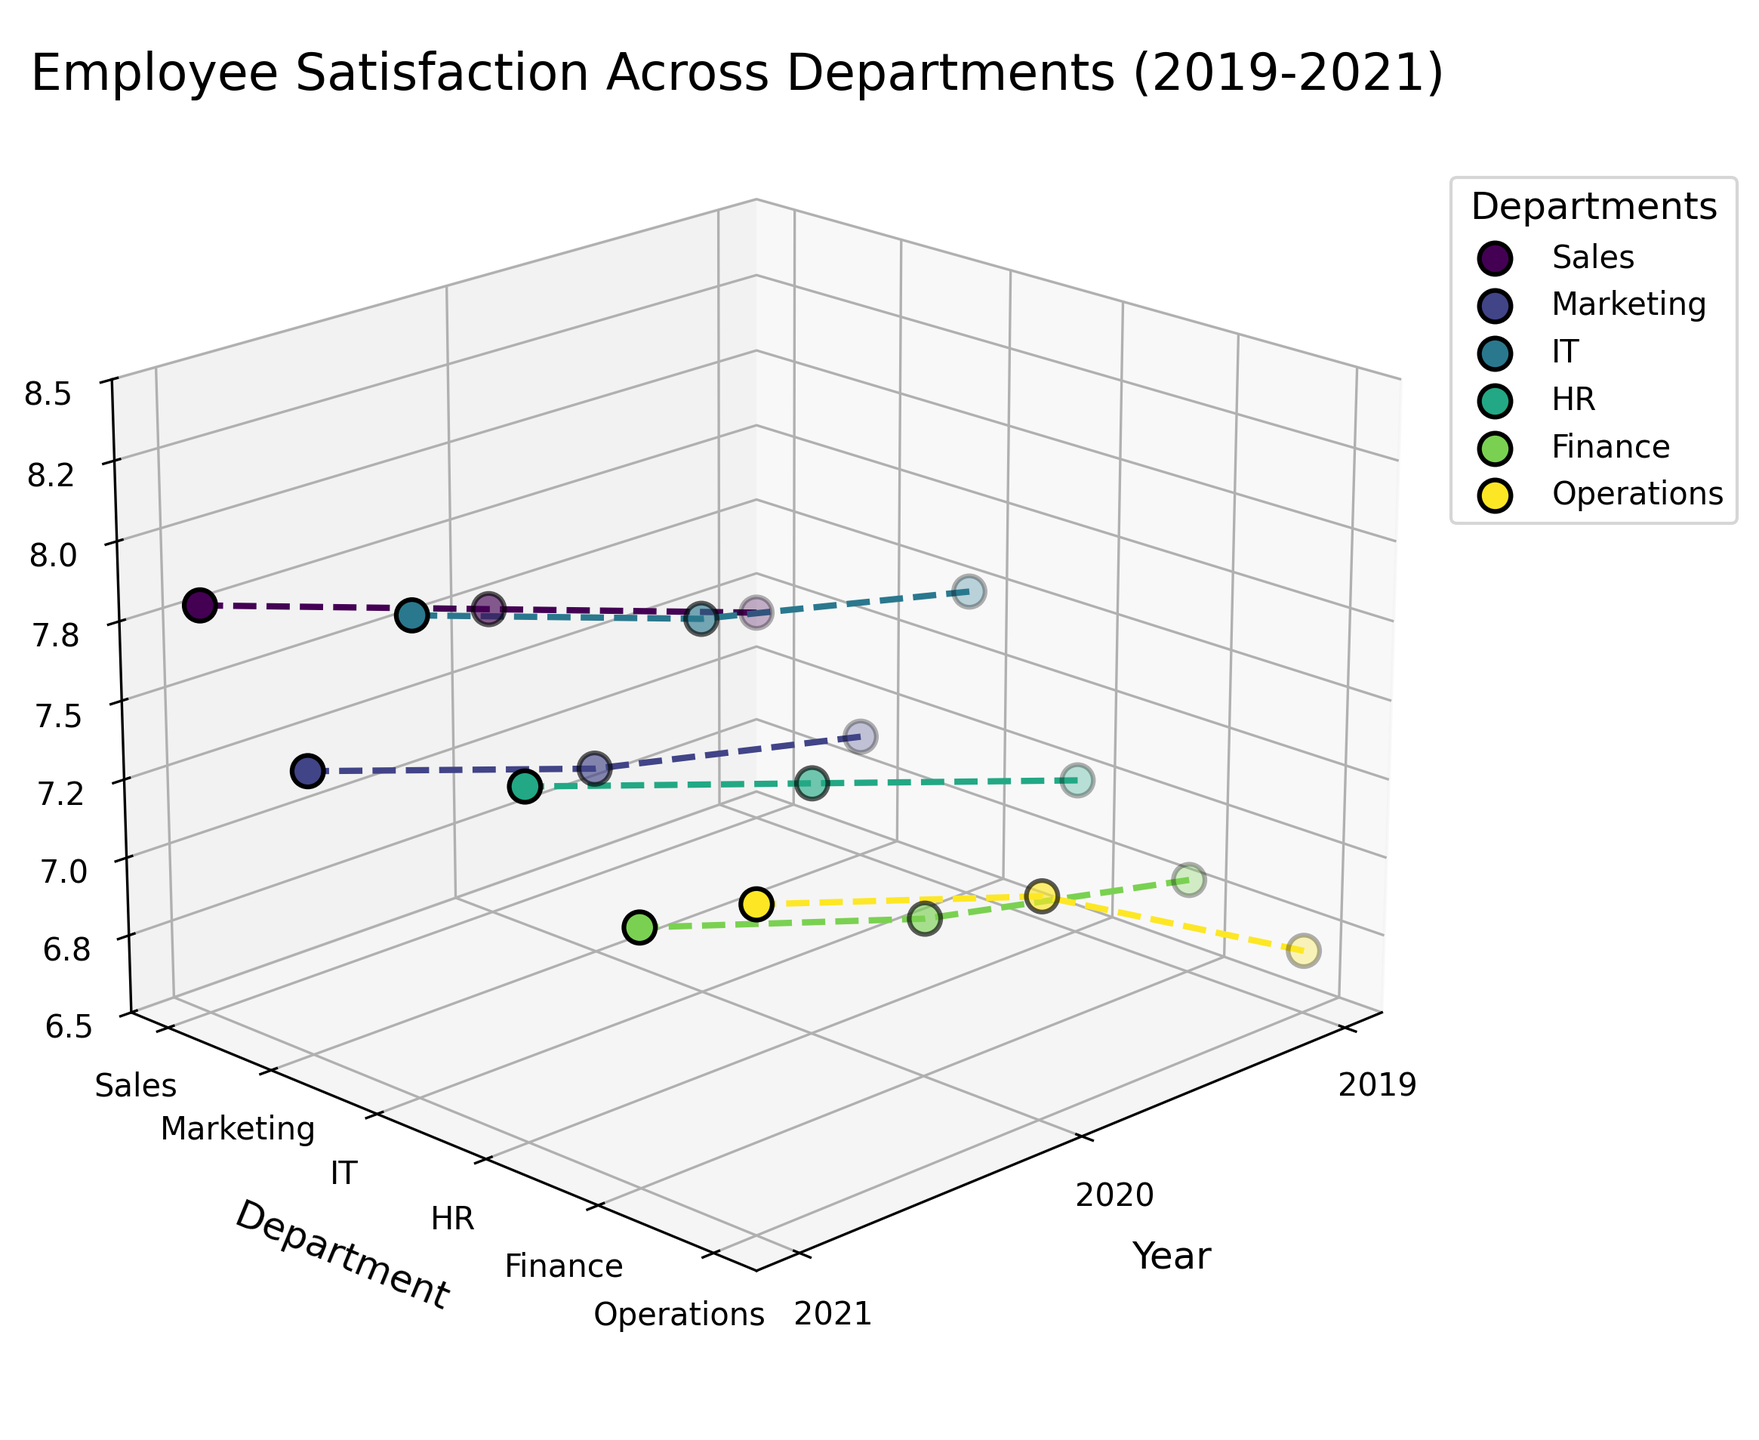What is the title of the figure? The title is typically displayed at the top of the figure. It summarizes the overall theme or subject of the plot.
Answer: Employee Satisfaction Across Departments (2019-2021) Which department has the highest satisfaction in 2021? To find this, locate the data points for 2021 on the x-axis and identify the department with the highest z-value.
Answer: IT How many departments are shown in the figure? Count the number of unique departments listed on the y-axis, which are also typically mentioned in the legend.
Answer: Six What is the general trend of satisfaction in the Operations department from 2019 to 2021? Follow the plotted line or data points for the Operations department across the years to observe the trend.
Answer: Increasing Which year had the lowest overall satisfaction across all departments? Compare the z-values (satisfaction) for each department across the years and identify the year with consistently lower values.
Answer: 2019 What is the satisfaction level in the Sales department in 2020? Locate the Sales department line and find the data point corresponding to the year 2020 to read the z-value.
Answer: 7.5 Which department showed the most improvement in satisfaction from 2019 to 2021? Calculate the difference in satisfaction levels between 2019 and 2021 for each department and find the maximum improvement.
Answer: Operations Is there any department that has a decreasing trend in satisfaction from 2019 to 2021? Examine each department's trend line from 2019 to 2021 and look for any downward trends.
Answer: No How does the satisfaction in Marketing in 2020 compare to HR in 2019? Locate the respective data points for Marketing in 2020 and HR in 2019, then compare their z-values.
Answer: Marketing in 2020 is higher What is the average satisfaction level of the IT department across all shown years? Sum the satisfaction levels of the IT department for 2019, 2020, and 2021, then divide by the number of years.
Answer: 7.73 